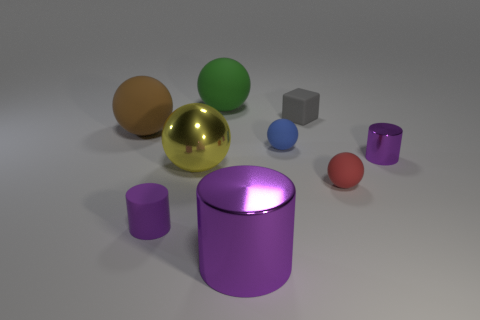There is a brown matte sphere; is its size the same as the cylinder that is left of the green ball?
Ensure brevity in your answer.  No. Is there any other thing that is the same shape as the gray matte object?
Your response must be concise. No. How many metallic things are either blue balls or gray things?
Provide a short and direct response. 0. What size is the matte sphere on the left side of the large green rubber sphere behind the yellow thing?
Your answer should be very brief. Large. What material is the big cylinder that is the same color as the small metallic cylinder?
Ensure brevity in your answer.  Metal. Are there any small purple cylinders that are to the left of the purple shiny thing that is in front of the thing to the right of the red matte sphere?
Your answer should be compact. Yes. Do the small cylinder behind the red object and the sphere behind the tiny matte block have the same material?
Offer a terse response. No. What number of objects are yellow balls or metallic cylinders on the left side of the tiny gray thing?
Offer a very short reply. 2. How many other big rubber objects have the same shape as the blue object?
Give a very brief answer. 2. There is a purple thing that is the same size as the brown thing; what material is it?
Offer a very short reply. Metal. 